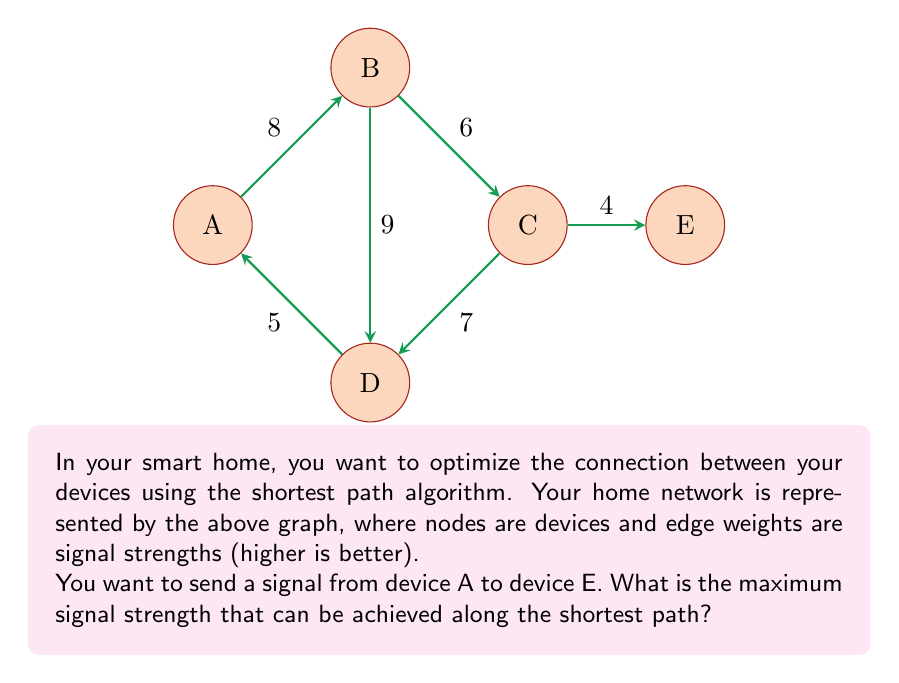Teach me how to tackle this problem. To solve this problem, we'll use Dijkstra's algorithm to find the shortest path with the highest signal strength. In this case, we want to maximize the minimum signal strength along the path.

Step 1: Initialize distances
Set distance to A as 0, and all others as -∞ (since we're maximizing).
$$d(A) = 0, d(B) = d(C) = d(D) = d(E) = -\infty$$

Step 2: Update neighbors of A
$$d(B) = \min(d(A), 8) = 8$$
$$d(D) = \min(d(A), 5) = 5$$

Step 3: Select B (highest value) and update its neighbors
$$d(C) = \min(d(B), 6) = 6$$
$$d(D) = \max(d(D), \min(d(B), 9)) = 8$$

Step 4: Select D and update its neighbors (no change)

Step 5: Select C and update its neighbors
$$d(E) = \min(d(C), 4) = 4$$

The algorithm terminates as we've reached E.

The shortest path with maximum signal strength is A → B → C → E, with a minimum signal strength of 4 along this path.
Answer: 4 